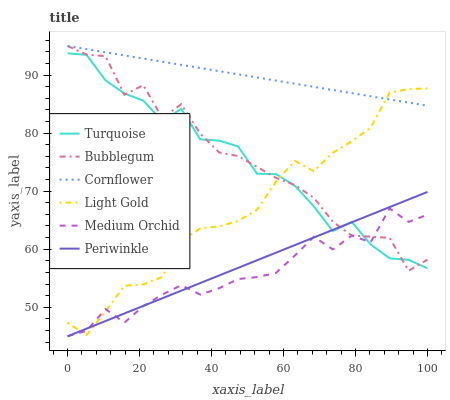Does Medium Orchid have the minimum area under the curve?
Answer yes or no. Yes. Does Cornflower have the maximum area under the curve?
Answer yes or no. Yes. Does Turquoise have the minimum area under the curve?
Answer yes or no. No. Does Turquoise have the maximum area under the curve?
Answer yes or no. No. Is Periwinkle the smoothest?
Answer yes or no. Yes. Is Bubblegum the roughest?
Answer yes or no. Yes. Is Turquoise the smoothest?
Answer yes or no. No. Is Turquoise the roughest?
Answer yes or no. No. Does Medium Orchid have the lowest value?
Answer yes or no. Yes. Does Turquoise have the lowest value?
Answer yes or no. No. Does Bubblegum have the highest value?
Answer yes or no. Yes. Does Turquoise have the highest value?
Answer yes or no. No. Is Medium Orchid less than Cornflower?
Answer yes or no. Yes. Is Cornflower greater than Turquoise?
Answer yes or no. Yes. Does Turquoise intersect Light Gold?
Answer yes or no. Yes. Is Turquoise less than Light Gold?
Answer yes or no. No. Is Turquoise greater than Light Gold?
Answer yes or no. No. Does Medium Orchid intersect Cornflower?
Answer yes or no. No. 